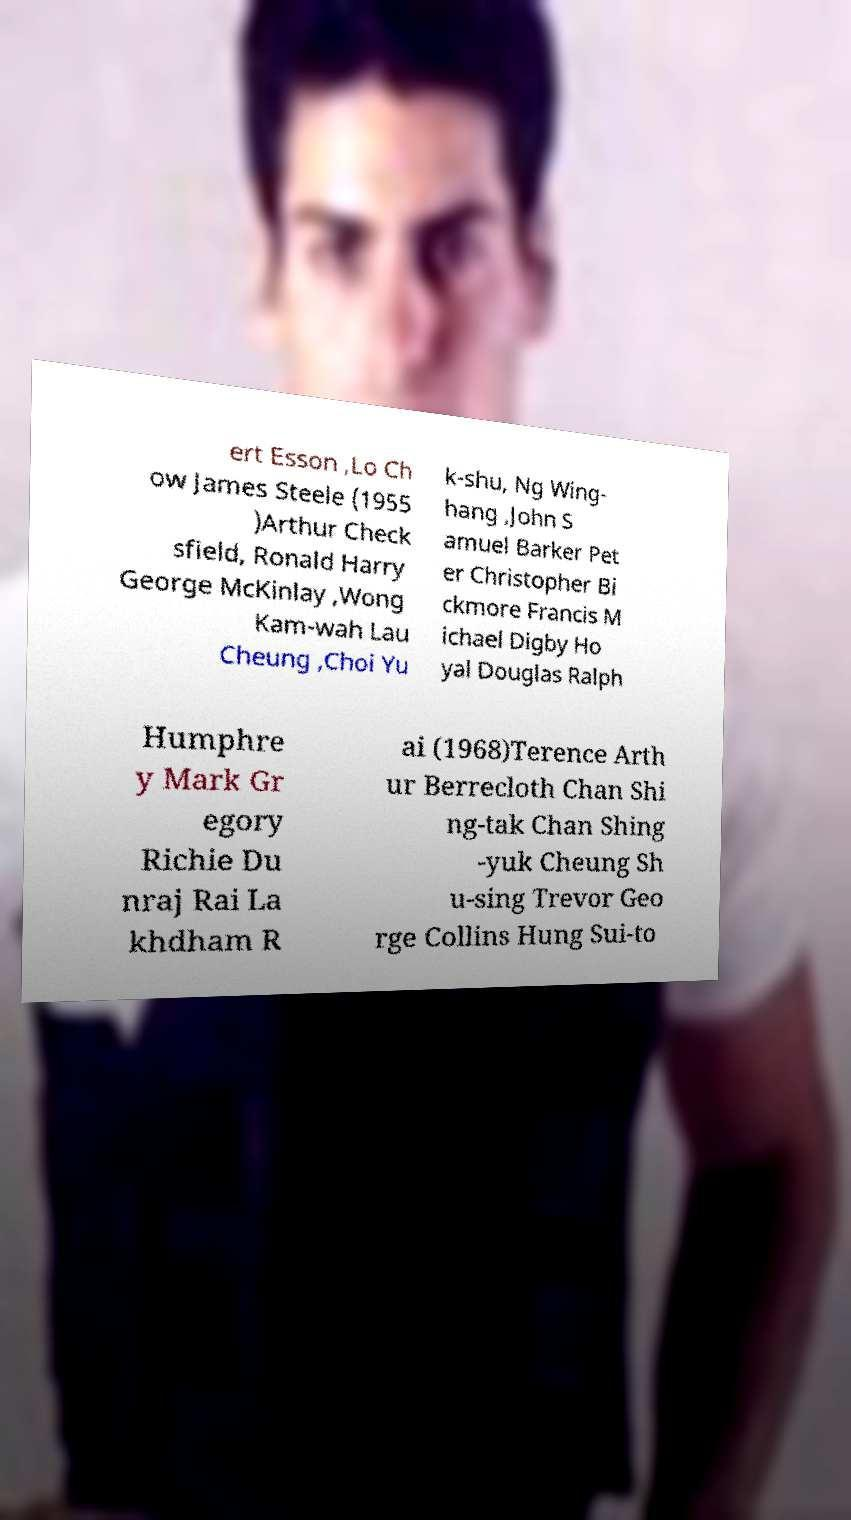What messages or text are displayed in this image? I need them in a readable, typed format. ert Esson ,Lo Ch ow James Steele (1955 )Arthur Check sfield, Ronald Harry George McKinlay ,Wong Kam-wah Lau Cheung ,Choi Yu k-shu, Ng Wing- hang ,John S amuel Barker Pet er Christopher Bi ckmore Francis M ichael Digby Ho yal Douglas Ralph Humphre y Mark Gr egory Richie Du nraj Rai La khdham R ai (1968)Terence Arth ur Berrecloth Chan Shi ng-tak Chan Shing -yuk Cheung Sh u-sing Trevor Geo rge Collins Hung Sui-to 